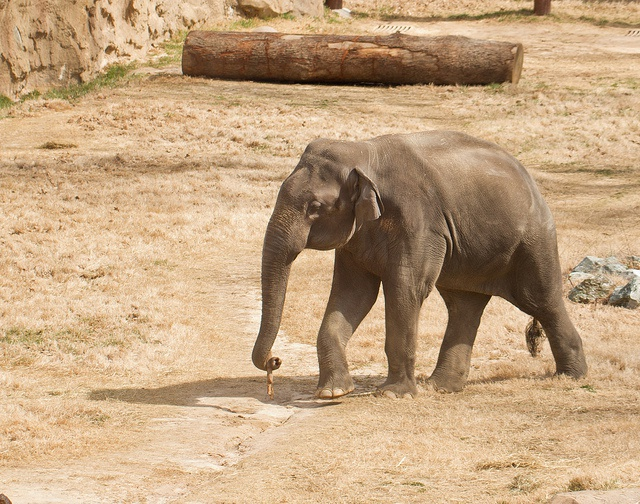Describe the objects in this image and their specific colors. I can see a elephant in tan, maroon, and gray tones in this image. 